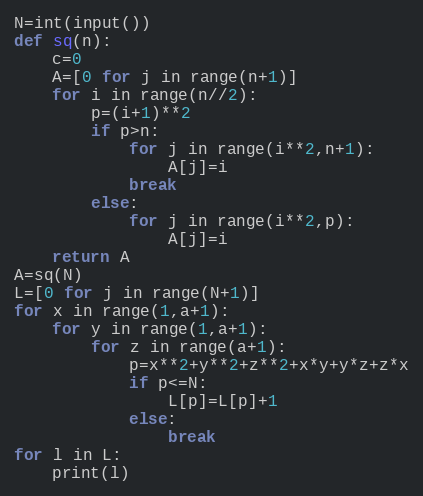<code> <loc_0><loc_0><loc_500><loc_500><_Python_>N=int(input())
def sq(n):
    c=0
    A=[0 for j in range(n+1)]
    for i in range(n//2):
        p=(i+1)**2
        if p>n:
            for j in range(i**2,n+1):
                A[j]=i
            break
        else:
            for j in range(i**2,p):
                A[j]=i
    return A
A=sq(N)
L=[0 for j in range(N+1)]
for x in range(1,a+1):
    for y in range(1,a+1):
        for z in range(a+1):
            p=x**2+y**2+z**2+x*y+y*z+z*x
            if p<=N:
                L[p]=L[p]+1
            else:
                break
for l in L:
    print(l)</code> 